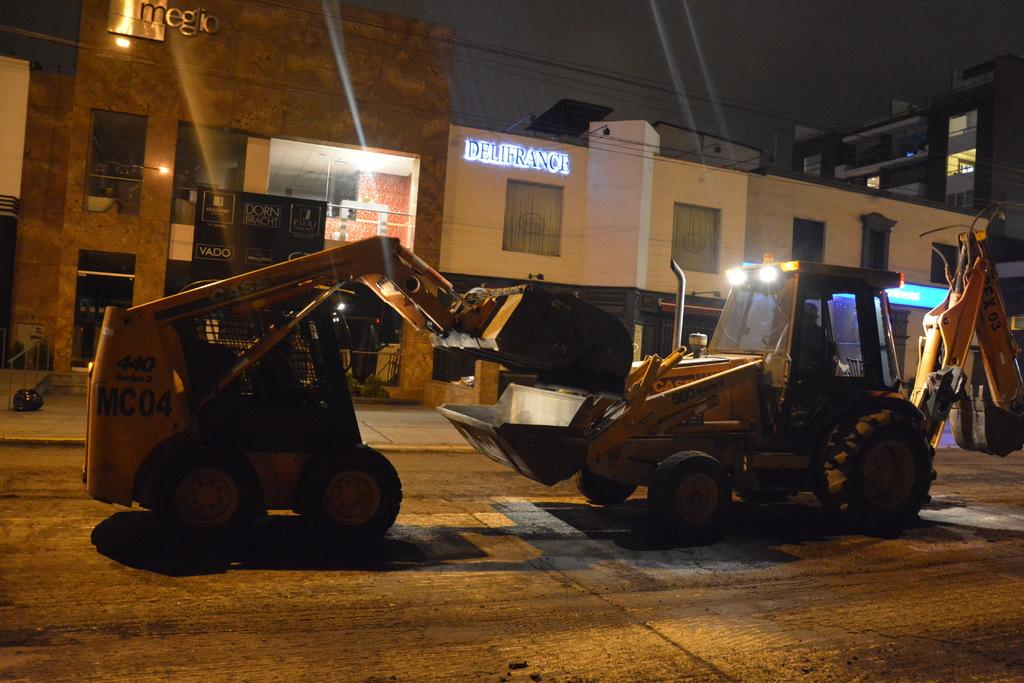Provide a one-sentence caption for the provided image. Two construction diggers face off in front of a Delifrance establishment. 